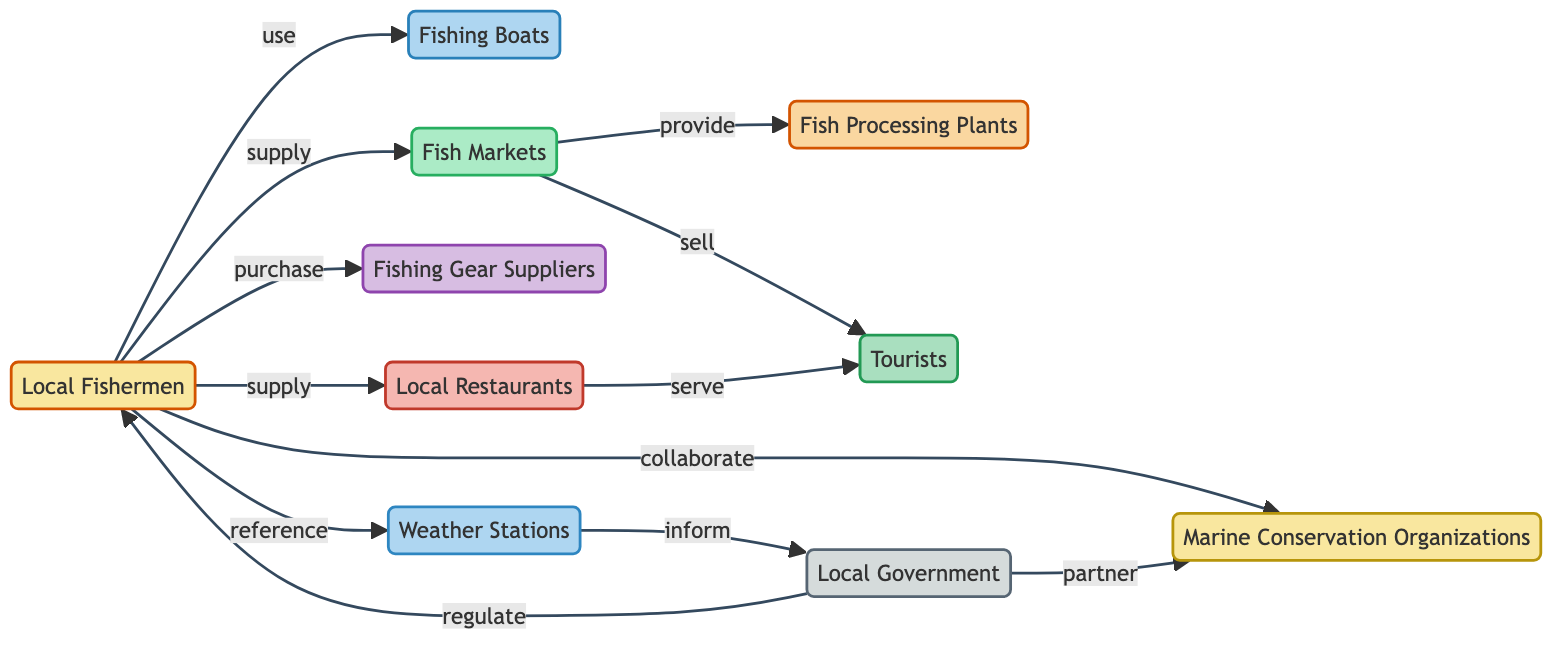What are the types of nodes in the diagram? The diagram contains nodes related to community, equipment, infrastructure, supplier, business, facility, consumer, authority, NGO, and data source.
Answer: community, equipment, infrastructure, supplier, business, facility, consumer, authority, ngo, data source How many nodes are present in the diagram? By counting each unique node listed (Local Fishermen, Fishing Boats, Fish Markets, etc.), we find a total of 10 nodes.
Answer: 10 What relationship exists between Local Fishermen and Fishing Boats? The diagram indicates a "use" relationship between Local Fishermen and Fishing Boats.
Answer: use How many relationships are there in total within the diagram? By counting all the edges (relationships) connecting the nodes, there are a total of 12 relationships present.
Answer: 12 Which entity do Local Fishermen collaborate with? According to the diagram, Local Fishermen have a "collaborate" relationship with Marine Conservation Organizations.
Answer: Marine Conservation Organizations How does Local Government interact with the Fish Markets? There is no direct relationship between Local Government and Fish Markets in the diagram, indicating that they do not interact directly.
Answer: none What type of relationship exists between Fish Markets and Tourists? The relationship depicted is "sell," showing that Fish Markets sell to Tourists.
Answer: sell Which type of node does Fishing Gear Suppliers represent? Fishing Gear Suppliers are classified as a "supplier" type node in the diagram.
Answer: supplier What is the relationship between Weather Stations and Local Government? The diagram shows an "inform" relationship where Weather Stations provide information to Local Government.
Answer: inform Which entities do Local Fishermen reference according to the diagram? Local Fishermen reference Weather Stations as indicated by the "reference" relationship in the diagram.
Answer: Weather Stations 